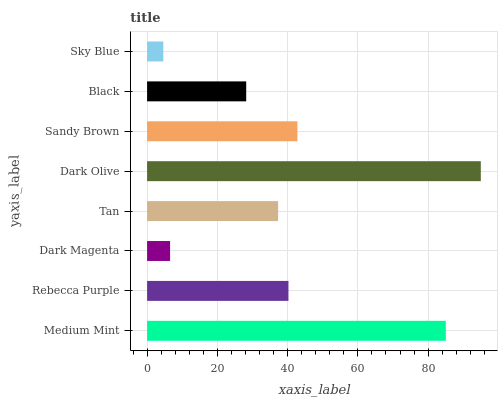Is Sky Blue the minimum?
Answer yes or no. Yes. Is Dark Olive the maximum?
Answer yes or no. Yes. Is Rebecca Purple the minimum?
Answer yes or no. No. Is Rebecca Purple the maximum?
Answer yes or no. No. Is Medium Mint greater than Rebecca Purple?
Answer yes or no. Yes. Is Rebecca Purple less than Medium Mint?
Answer yes or no. Yes. Is Rebecca Purple greater than Medium Mint?
Answer yes or no. No. Is Medium Mint less than Rebecca Purple?
Answer yes or no. No. Is Rebecca Purple the high median?
Answer yes or no. Yes. Is Tan the low median?
Answer yes or no. Yes. Is Medium Mint the high median?
Answer yes or no. No. Is Sandy Brown the low median?
Answer yes or no. No. 